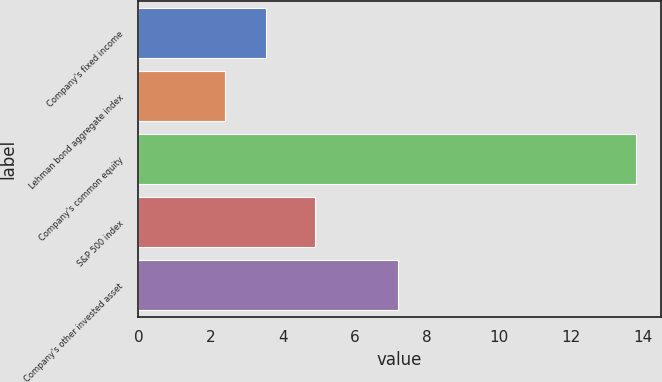<chart> <loc_0><loc_0><loc_500><loc_500><bar_chart><fcel>Company's fixed income<fcel>Lehman bond aggregate index<fcel>Company's common equity<fcel>S&P 500 index<fcel>Company's other invested asset<nl><fcel>3.54<fcel>2.4<fcel>13.8<fcel>4.9<fcel>7.2<nl></chart> 